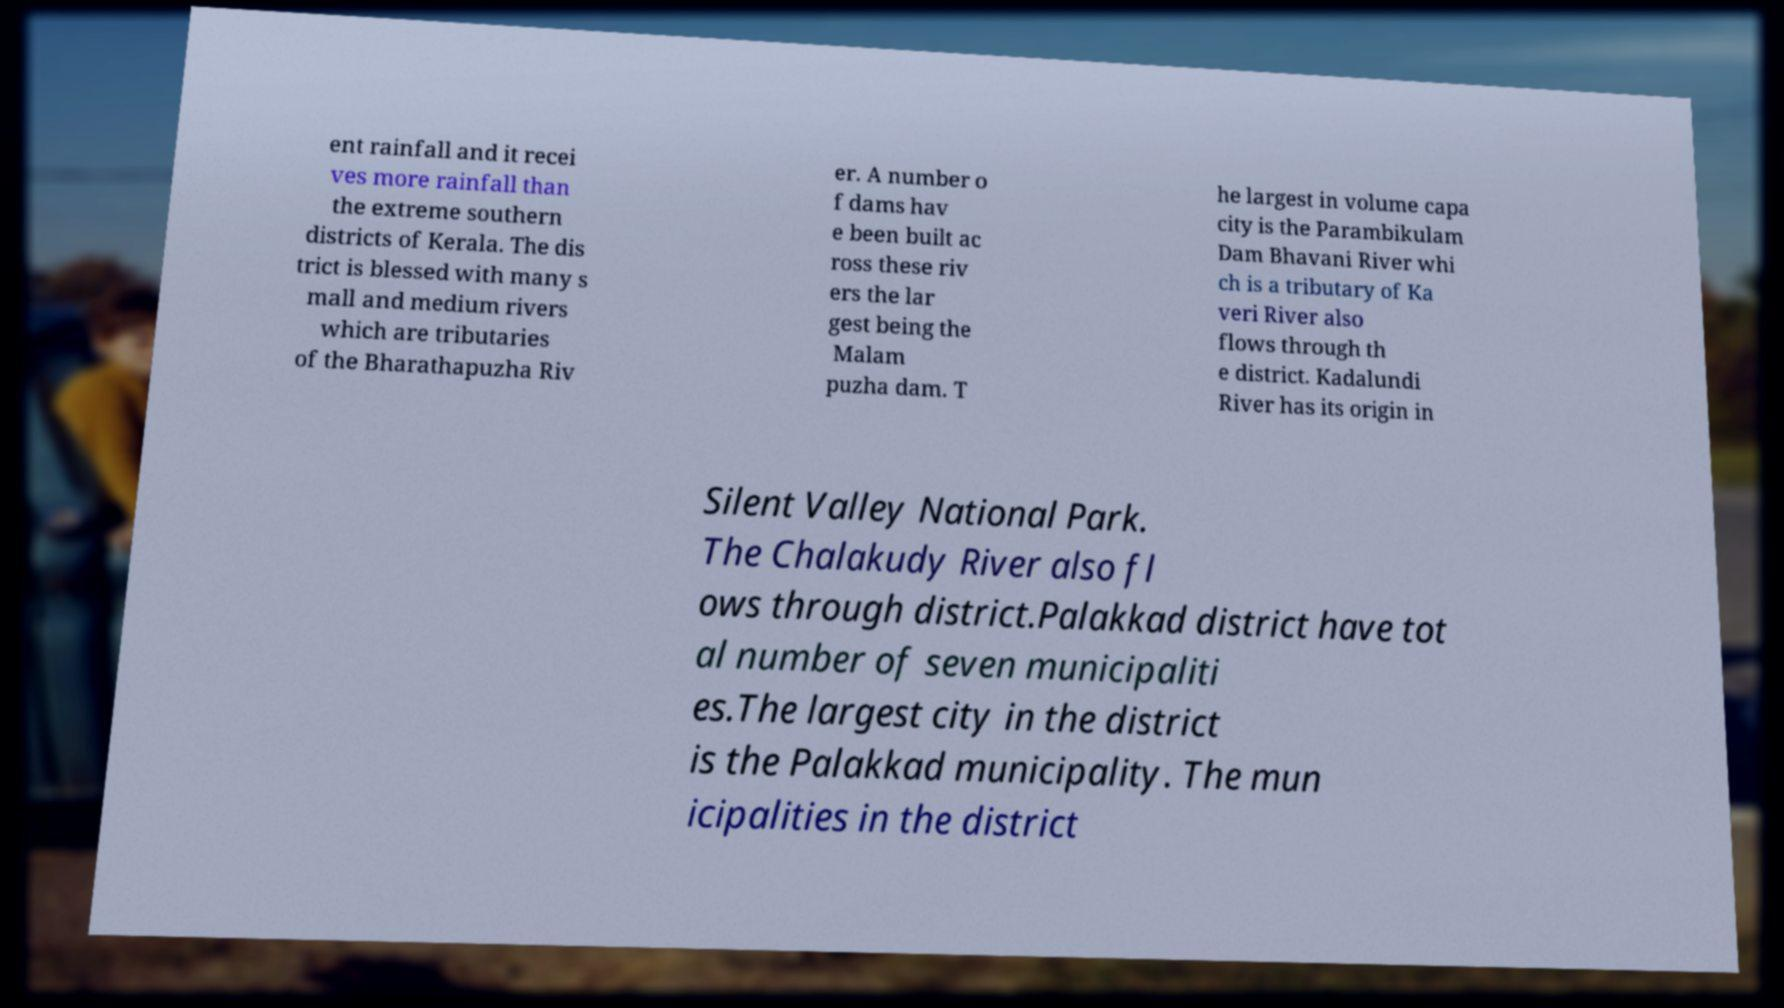There's text embedded in this image that I need extracted. Can you transcribe it verbatim? ent rainfall and it recei ves more rainfall than the extreme southern districts of Kerala. The dis trict is blessed with many s mall and medium rivers which are tributaries of the Bharathapuzha Riv er. A number o f dams hav e been built ac ross these riv ers the lar gest being the Malam puzha dam. T he largest in volume capa city is the Parambikulam Dam Bhavani River whi ch is a tributary of Ka veri River also flows through th e district. Kadalundi River has its origin in Silent Valley National Park. The Chalakudy River also fl ows through district.Palakkad district have tot al number of seven municipaliti es.The largest city in the district is the Palakkad municipality. The mun icipalities in the district 